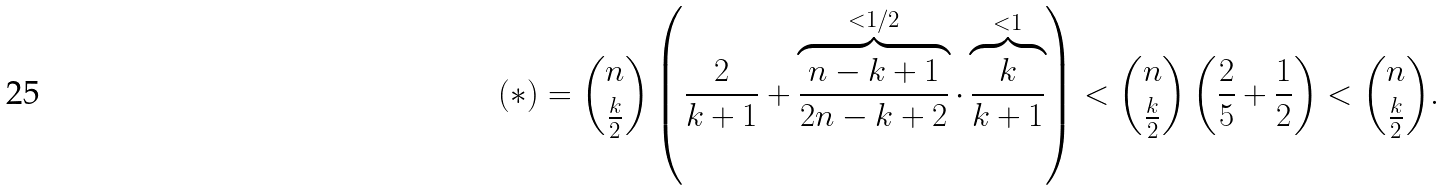Convert formula to latex. <formula><loc_0><loc_0><loc_500><loc_500>( * ) = \binom { n } { \frac { k } { 2 } } \left ( \frac { 2 } { k + 1 } + \overbrace { \frac { n - k + 1 } { 2 n - k + 2 } } ^ { < 1 / 2 } \cdot \overbrace { \frac { k } { k + 1 } } ^ { < 1 } \right ) < \binom { n } { \frac { k } { 2 } } \left ( \frac { 2 } { 5 } + \frac { 1 } { 2 } \right ) < \binom { n } { \frac { k } { 2 } } .</formula> 